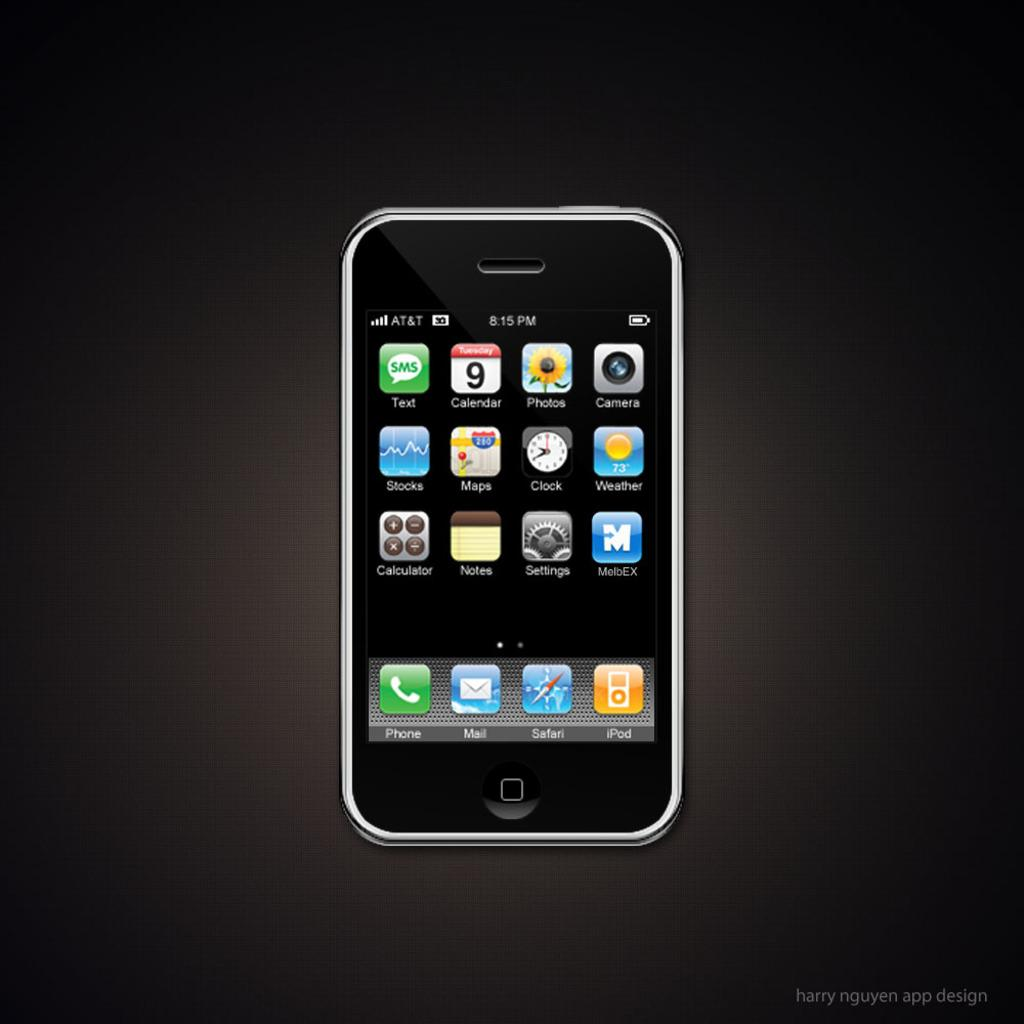Provide a one-sentence caption for the provided image. Iphone that show the home screen that contains different apps. 